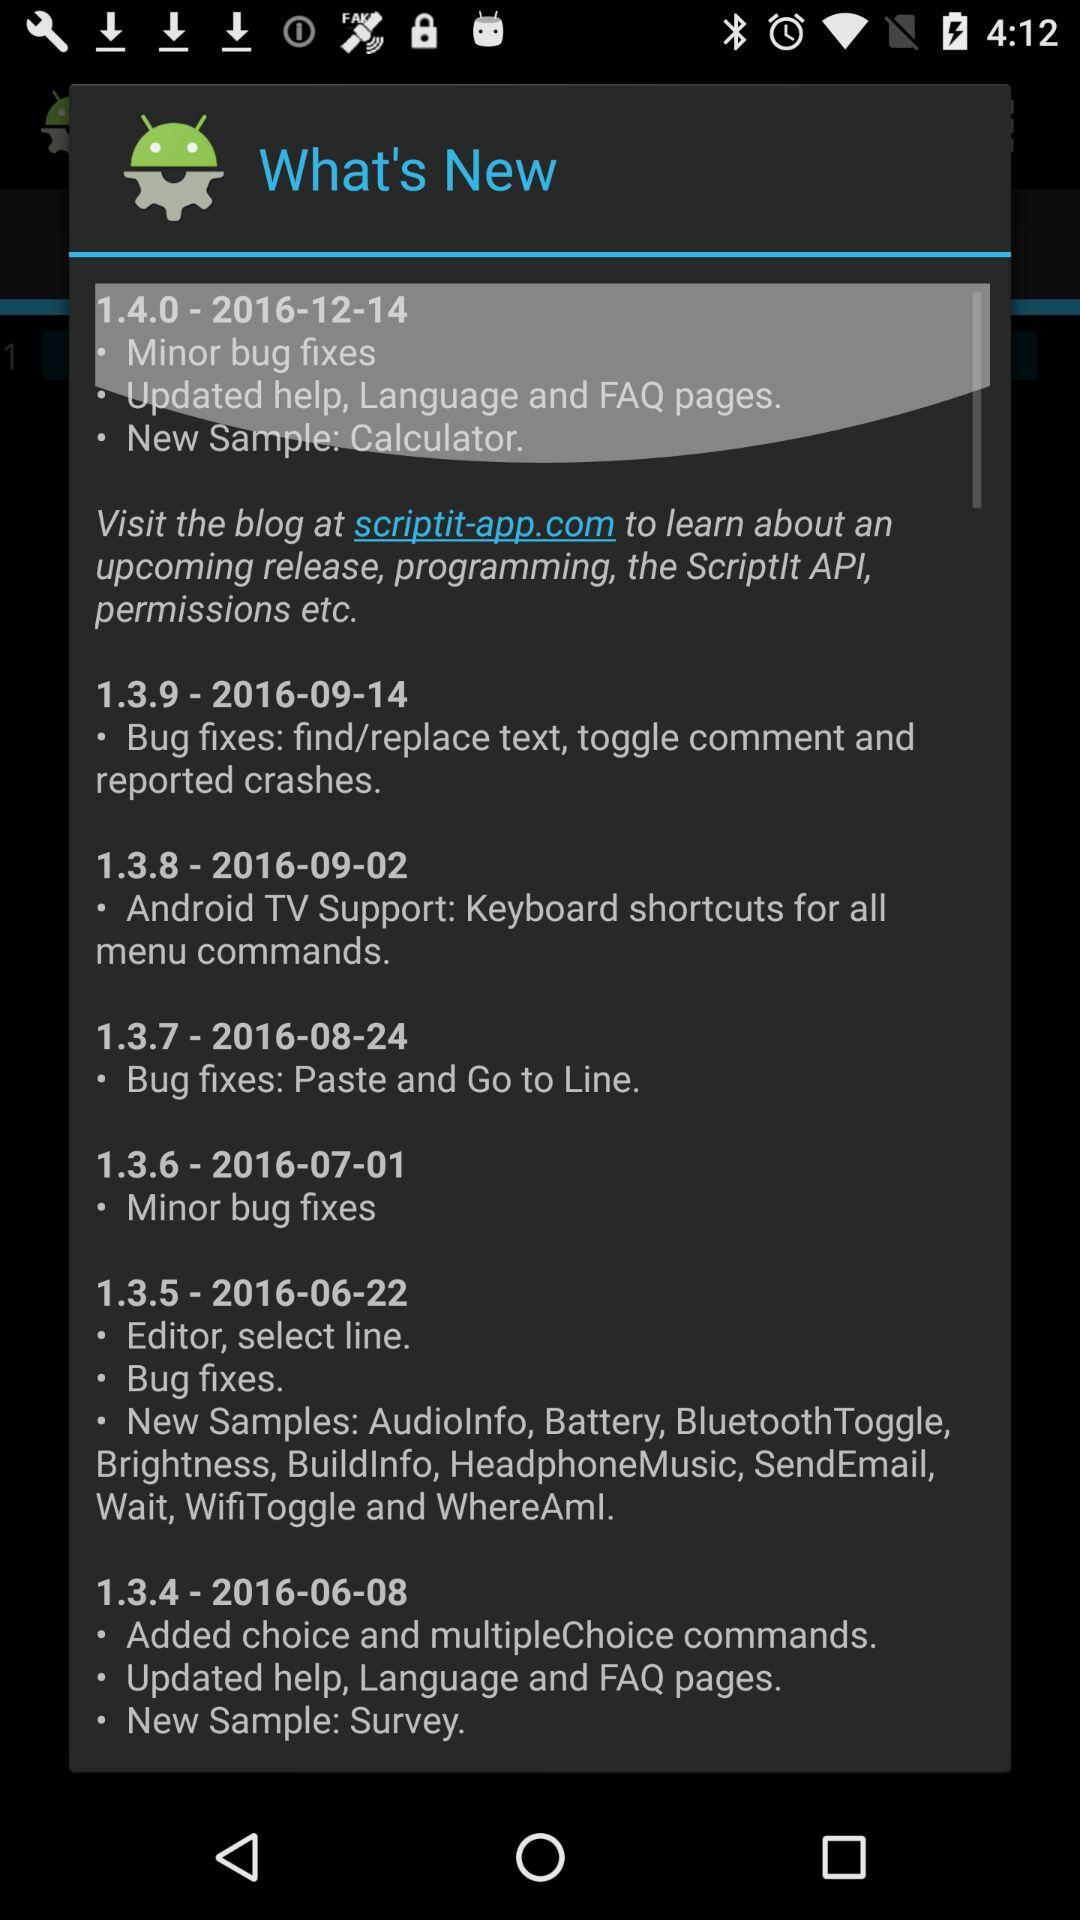What version is updated on 2016-12-14? The updated version is 1.4.0. 